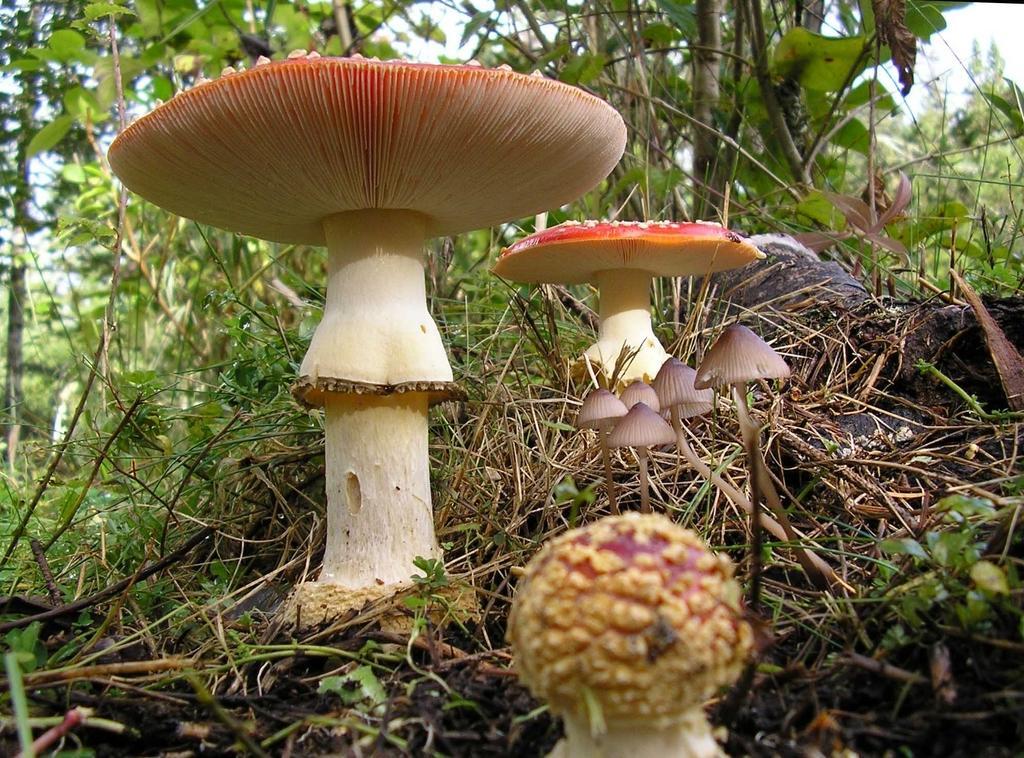Could you give a brief overview of what you see in this image? In the picture I can see mushrooms are in the ground, behind we can see so many trees. 